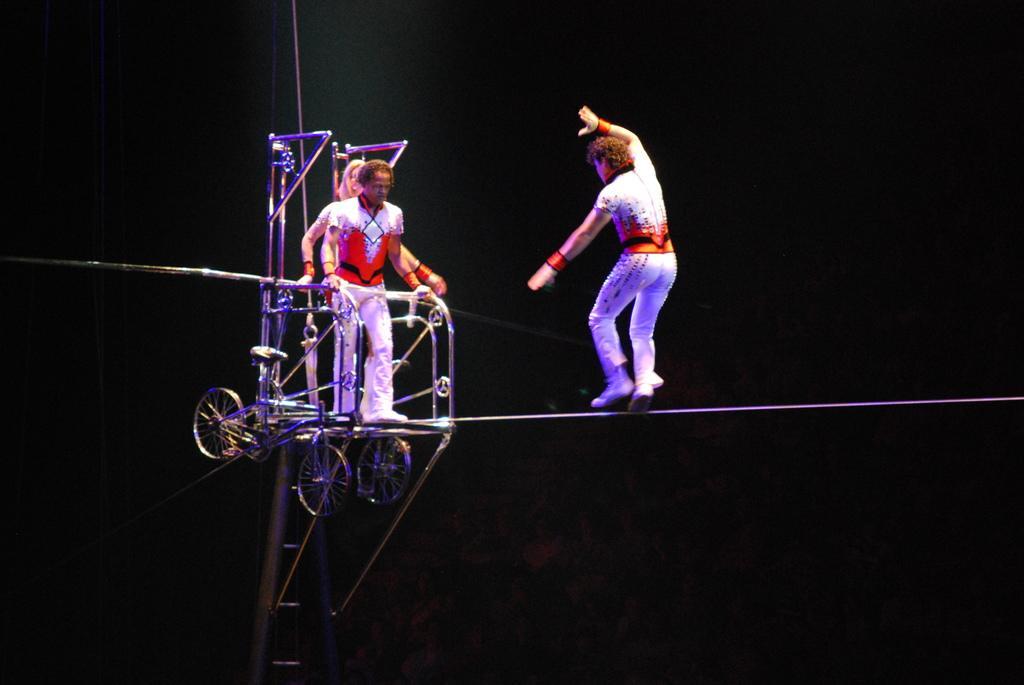Describe this image in one or two sentences. In this picture we can see three people and a man on a rope, wheels, rods and some objects and in the background it is dark. 